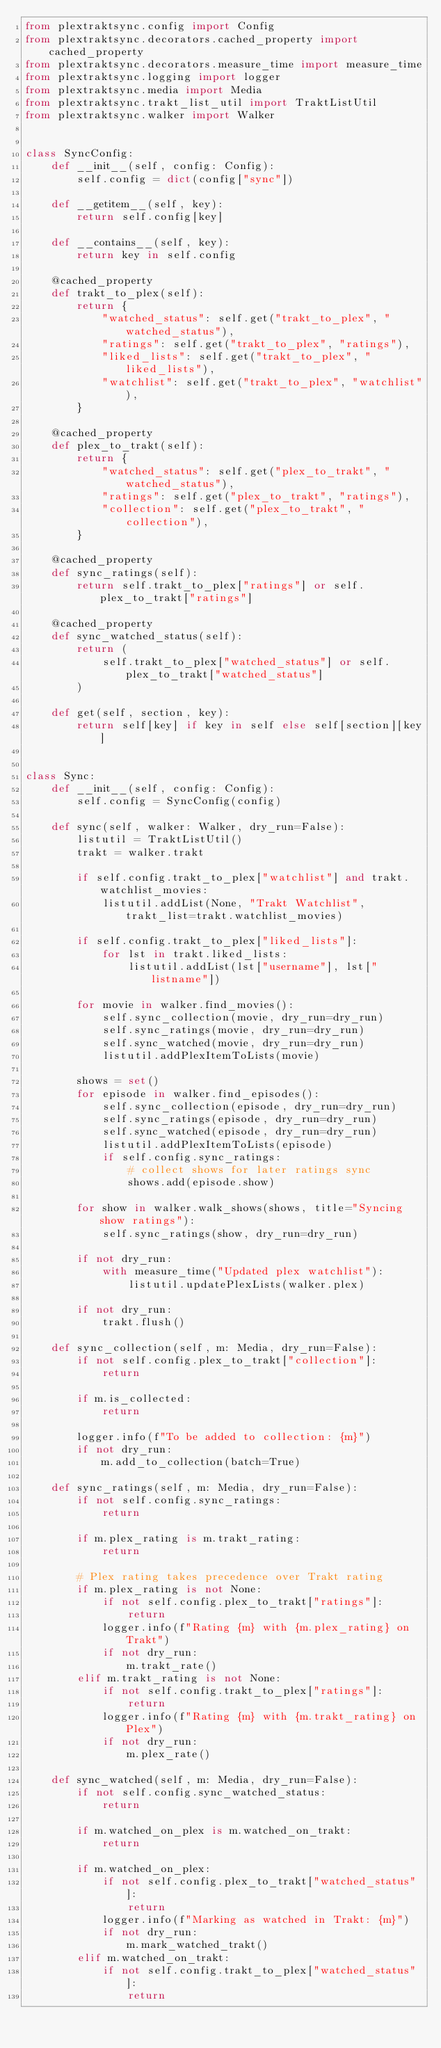<code> <loc_0><loc_0><loc_500><loc_500><_Python_>from plextraktsync.config import Config
from plextraktsync.decorators.cached_property import cached_property
from plextraktsync.decorators.measure_time import measure_time
from plextraktsync.logging import logger
from plextraktsync.media import Media
from plextraktsync.trakt_list_util import TraktListUtil
from plextraktsync.walker import Walker


class SyncConfig:
    def __init__(self, config: Config):
        self.config = dict(config["sync"])

    def __getitem__(self, key):
        return self.config[key]

    def __contains__(self, key):
        return key in self.config

    @cached_property
    def trakt_to_plex(self):
        return {
            "watched_status": self.get("trakt_to_plex", "watched_status"),
            "ratings": self.get("trakt_to_plex", "ratings"),
            "liked_lists": self.get("trakt_to_plex", "liked_lists"),
            "watchlist": self.get("trakt_to_plex", "watchlist"),
        }

    @cached_property
    def plex_to_trakt(self):
        return {
            "watched_status": self.get("plex_to_trakt", "watched_status"),
            "ratings": self.get("plex_to_trakt", "ratings"),
            "collection": self.get("plex_to_trakt", "collection"),
        }

    @cached_property
    def sync_ratings(self):
        return self.trakt_to_plex["ratings"] or self.plex_to_trakt["ratings"]

    @cached_property
    def sync_watched_status(self):
        return (
            self.trakt_to_plex["watched_status"] or self.plex_to_trakt["watched_status"]
        )

    def get(self, section, key):
        return self[key] if key in self else self[section][key]


class Sync:
    def __init__(self, config: Config):
        self.config = SyncConfig(config)

    def sync(self, walker: Walker, dry_run=False):
        listutil = TraktListUtil()
        trakt = walker.trakt

        if self.config.trakt_to_plex["watchlist"] and trakt.watchlist_movies:
            listutil.addList(None, "Trakt Watchlist", trakt_list=trakt.watchlist_movies)

        if self.config.trakt_to_plex["liked_lists"]:
            for lst in trakt.liked_lists:
                listutil.addList(lst["username"], lst["listname"])

        for movie in walker.find_movies():
            self.sync_collection(movie, dry_run=dry_run)
            self.sync_ratings(movie, dry_run=dry_run)
            self.sync_watched(movie, dry_run=dry_run)
            listutil.addPlexItemToLists(movie)

        shows = set()
        for episode in walker.find_episodes():
            self.sync_collection(episode, dry_run=dry_run)
            self.sync_ratings(episode, dry_run=dry_run)
            self.sync_watched(episode, dry_run=dry_run)
            listutil.addPlexItemToLists(episode)
            if self.config.sync_ratings:
                # collect shows for later ratings sync
                shows.add(episode.show)

        for show in walker.walk_shows(shows, title="Syncing show ratings"):
            self.sync_ratings(show, dry_run=dry_run)

        if not dry_run:
            with measure_time("Updated plex watchlist"):
                listutil.updatePlexLists(walker.plex)

        if not dry_run:
            trakt.flush()

    def sync_collection(self, m: Media, dry_run=False):
        if not self.config.plex_to_trakt["collection"]:
            return

        if m.is_collected:
            return

        logger.info(f"To be added to collection: {m}")
        if not dry_run:
            m.add_to_collection(batch=True)

    def sync_ratings(self, m: Media, dry_run=False):
        if not self.config.sync_ratings:
            return

        if m.plex_rating is m.trakt_rating:
            return

        # Plex rating takes precedence over Trakt rating
        if m.plex_rating is not None:
            if not self.config.plex_to_trakt["ratings"]:
                return
            logger.info(f"Rating {m} with {m.plex_rating} on Trakt")
            if not dry_run:
                m.trakt_rate()
        elif m.trakt_rating is not None:
            if not self.config.trakt_to_plex["ratings"]:
                return
            logger.info(f"Rating {m} with {m.trakt_rating} on Plex")
            if not dry_run:
                m.plex_rate()

    def sync_watched(self, m: Media, dry_run=False):
        if not self.config.sync_watched_status:
            return

        if m.watched_on_plex is m.watched_on_trakt:
            return

        if m.watched_on_plex:
            if not self.config.plex_to_trakt["watched_status"]:
                return
            logger.info(f"Marking as watched in Trakt: {m}")
            if not dry_run:
                m.mark_watched_trakt()
        elif m.watched_on_trakt:
            if not self.config.trakt_to_plex["watched_status"]:
                return</code> 